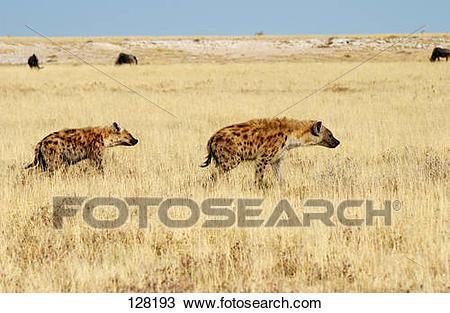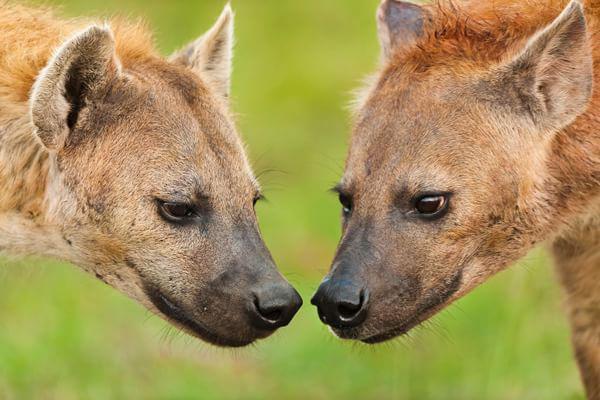The first image is the image on the left, the second image is the image on the right. Examine the images to the left and right. Is the description "The left image includes a fang-baring hyena with wide open mouth, and the right image contains exactly two hyenas in matching poses." accurate? Answer yes or no. No. The first image is the image on the left, the second image is the image on the right. Evaluate the accuracy of this statement regarding the images: "The left image contains at least two hyenas.". Is it true? Answer yes or no. Yes. 